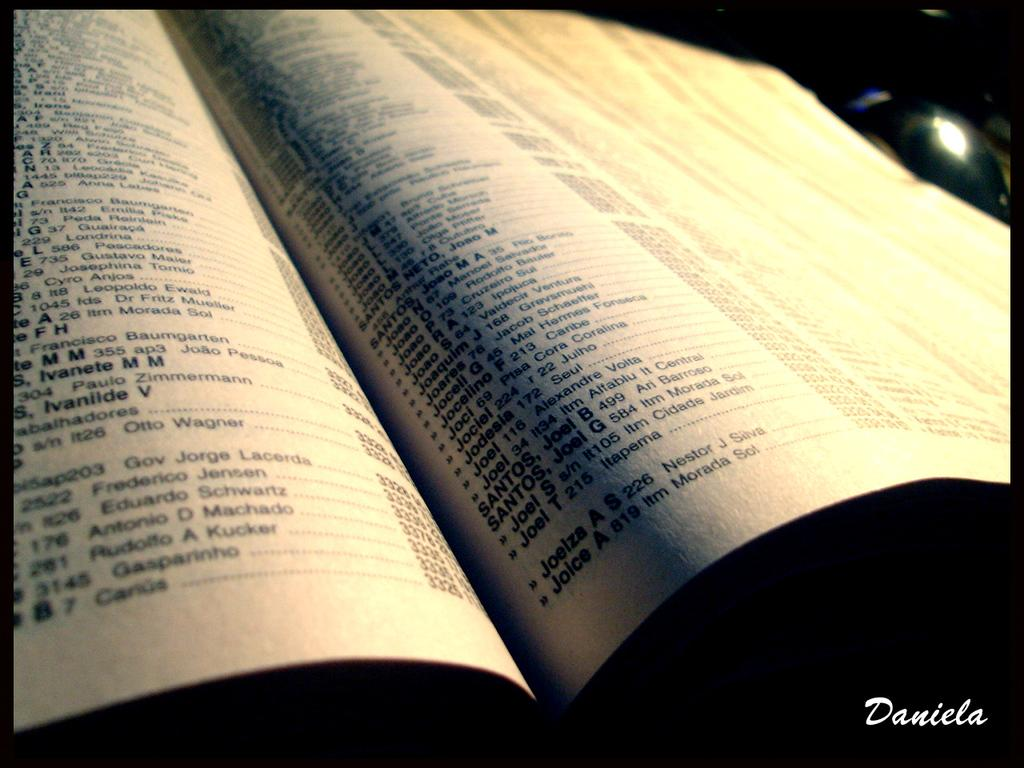<image>
Create a compact narrative representing the image presented. A phonebook with the name Daniela printed in the bottom right. 